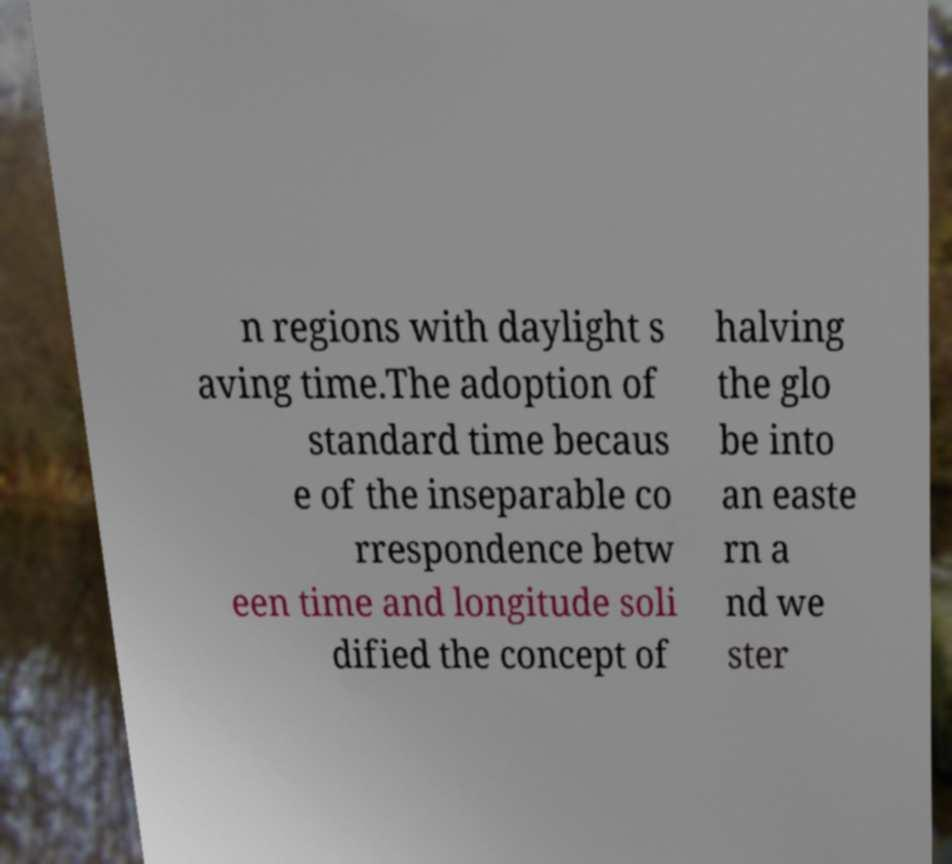For documentation purposes, I need the text within this image transcribed. Could you provide that? n regions with daylight s aving time.The adoption of standard time becaus e of the inseparable co rrespondence betw een time and longitude soli dified the concept of halving the glo be into an easte rn a nd we ster 